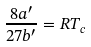Convert formula to latex. <formula><loc_0><loc_0><loc_500><loc_500>\frac { 8 a ^ { \prime } } { 2 7 b ^ { \prime } } = R T _ { c }</formula> 